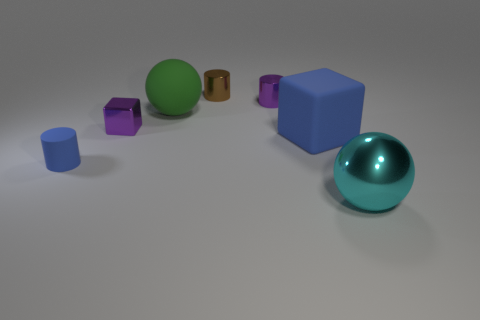What size is the other thing that is the same color as the small matte thing?
Make the answer very short. Large. There is a small purple metal thing behind the green matte ball; is it the same shape as the tiny brown metallic object?
Offer a very short reply. Yes. There is a small blue thing that is the same shape as the brown thing; what material is it?
Make the answer very short. Rubber. How many metallic cylinders are the same size as the brown metal thing?
Offer a very short reply. 1. What color is the tiny cylinder that is both in front of the brown metal thing and behind the large green object?
Make the answer very short. Purple. Are there fewer metallic blocks than tiny blue rubber spheres?
Provide a short and direct response. No. Does the small rubber cylinder have the same color as the matte thing to the right of the green rubber thing?
Offer a terse response. Yes. Are there an equal number of large green rubber spheres that are behind the brown metallic object and tiny matte cylinders to the right of the big cyan metal ball?
Your response must be concise. Yes. What number of other tiny brown objects are the same shape as the small rubber thing?
Provide a short and direct response. 1. Is there a metal sphere?
Your response must be concise. Yes. 